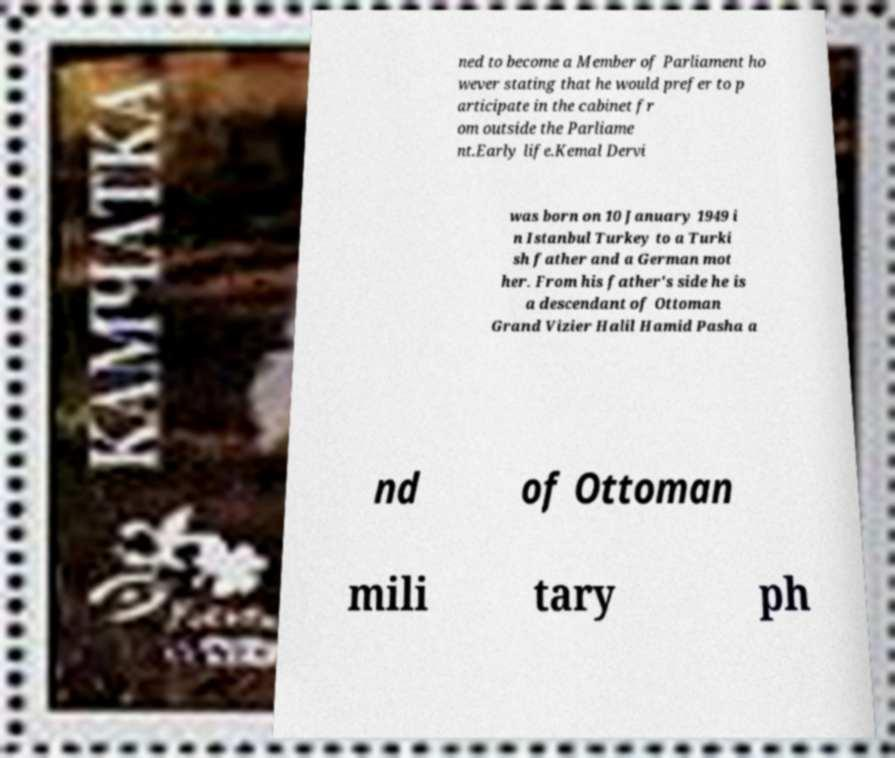I need the written content from this picture converted into text. Can you do that? ned to become a Member of Parliament ho wever stating that he would prefer to p articipate in the cabinet fr om outside the Parliame nt.Early life.Kemal Dervi was born on 10 January 1949 i n Istanbul Turkey to a Turki sh father and a German mot her. From his father's side he is a descendant of Ottoman Grand Vizier Halil Hamid Pasha a nd of Ottoman mili tary ph 